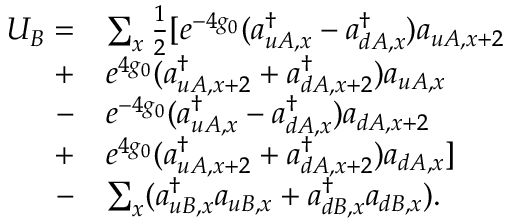<formula> <loc_0><loc_0><loc_500><loc_500>\begin{array} { r l } { U _ { B } = } & { \sum _ { x } \frac { 1 } { 2 } [ e ^ { - 4 g _ { 0 } } ( a _ { u A , x } ^ { \dagger } - a _ { d A , x } ^ { \dagger } ) a _ { u A , x + 2 } } \\ { + } & { e ^ { 4 g _ { 0 } } ( a _ { u A , x + 2 } ^ { \dagger } + a _ { d A , x + 2 } ^ { \dagger } ) a _ { u A , x } } \\ { - } & { e ^ { - 4 g _ { 0 } } ( a _ { u A , x } ^ { \dagger } - a _ { d A , x } ^ { \dagger } ) a _ { d A , x + 2 } } \\ { + } & { e ^ { 4 g _ { 0 } } ( a _ { u A , x + 2 } ^ { \dagger } + a _ { d A , x + 2 } ^ { \dagger } ) a _ { d A , x } ] } \\ { - } & { \sum _ { x } ( a _ { u B , x } ^ { \dagger } a _ { u B , x } + a _ { d B , x } ^ { \dagger } a _ { d B , x } ) . } \end{array}</formula> 